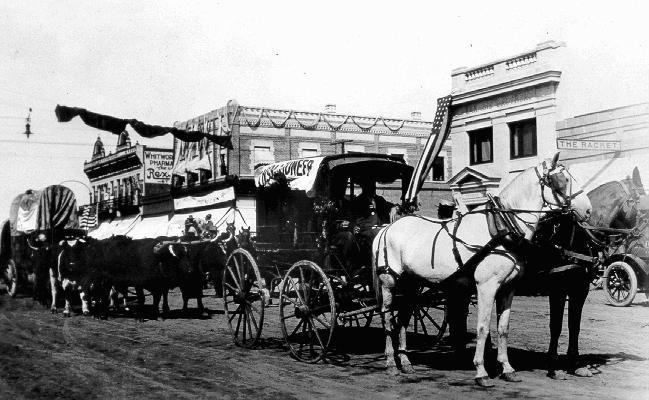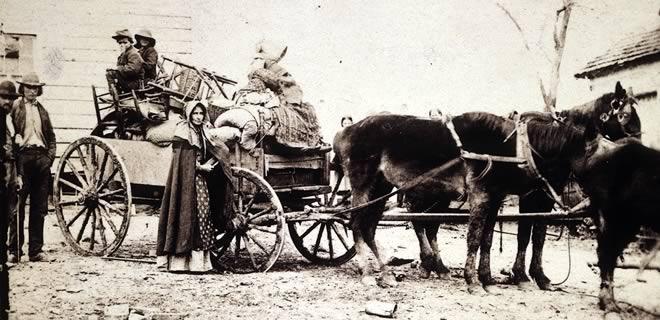The first image is the image on the left, the second image is the image on the right. Assess this claim about the two images: "A man sits on a horse wagon that has only 2 wheels.". Correct or not? Answer yes or no. No. 